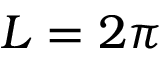<formula> <loc_0><loc_0><loc_500><loc_500>L = 2 \pi</formula> 